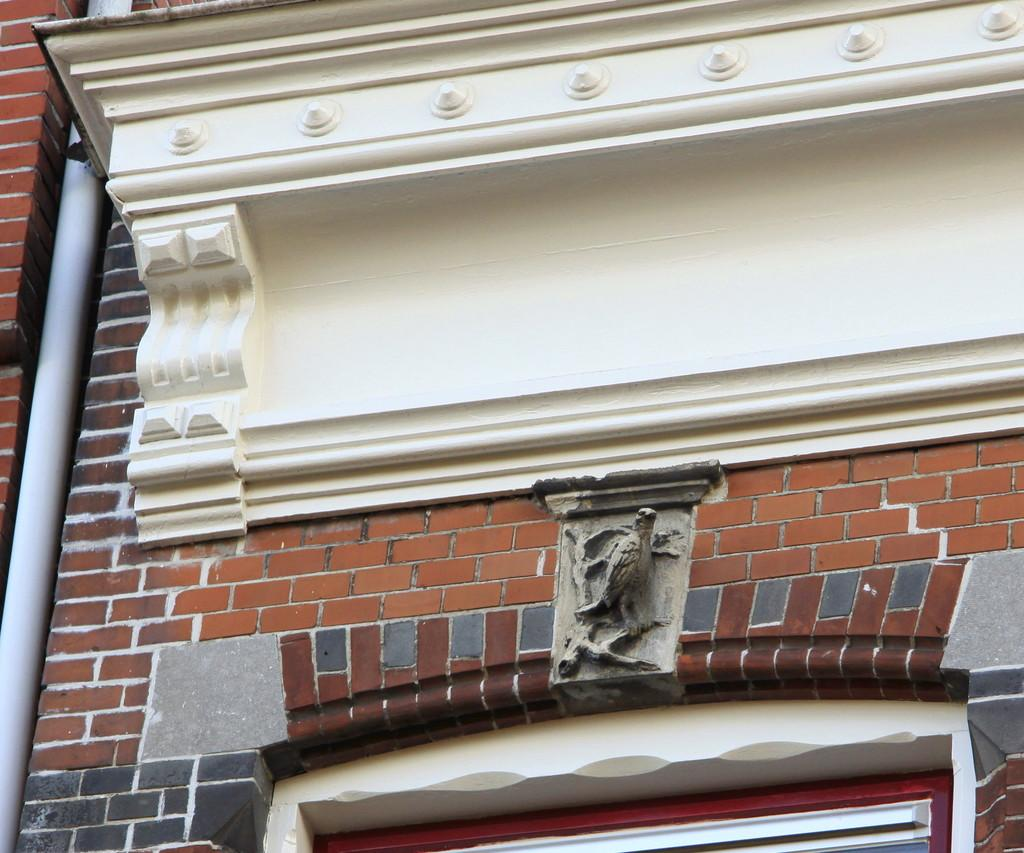What type of architectural feature can be seen in the image? There is a wall in the image. What decorative element is present on the wall? There is a cornice on the wall. What is located below the cornice? There is a sculpture below the cornice. What is situated below the sculpture? There is a window below the sculpture. What can be seen on the left side of the image? There is a pipe on the left side of the image. What type of veil is draped over the cornice in the image? There is no veil present in the image; only the cornice, sculpture, window, and pipe are visible. 